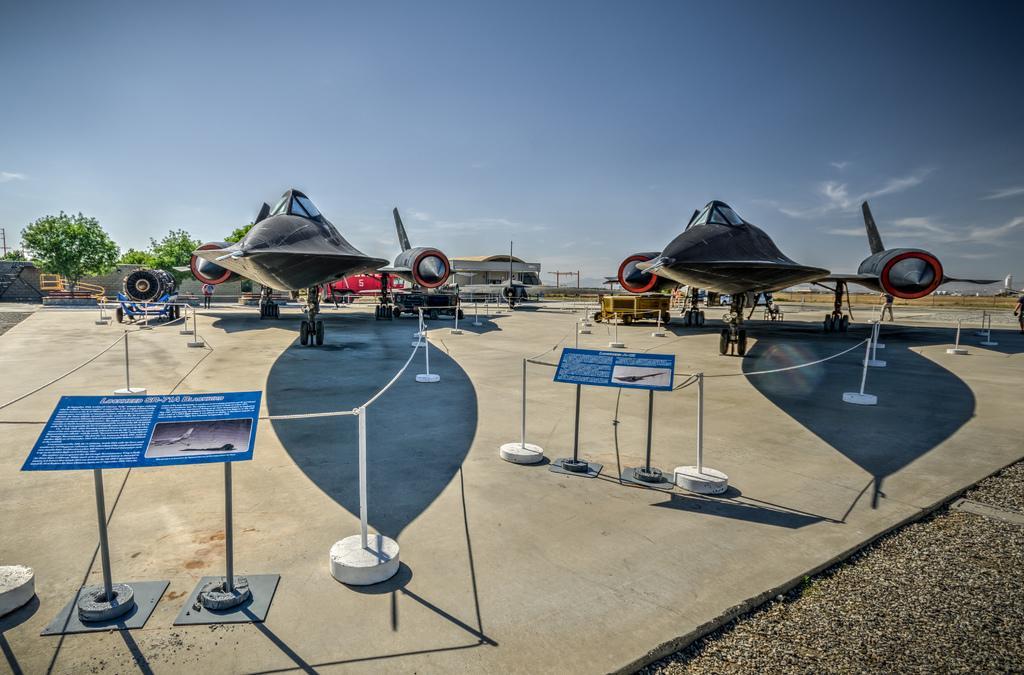Describe this image in one or two sentences. In this image we can see a few people there are boards with some text on them, there is fencing, there are aircrafts, trees, also we can see a building, and the sky. 